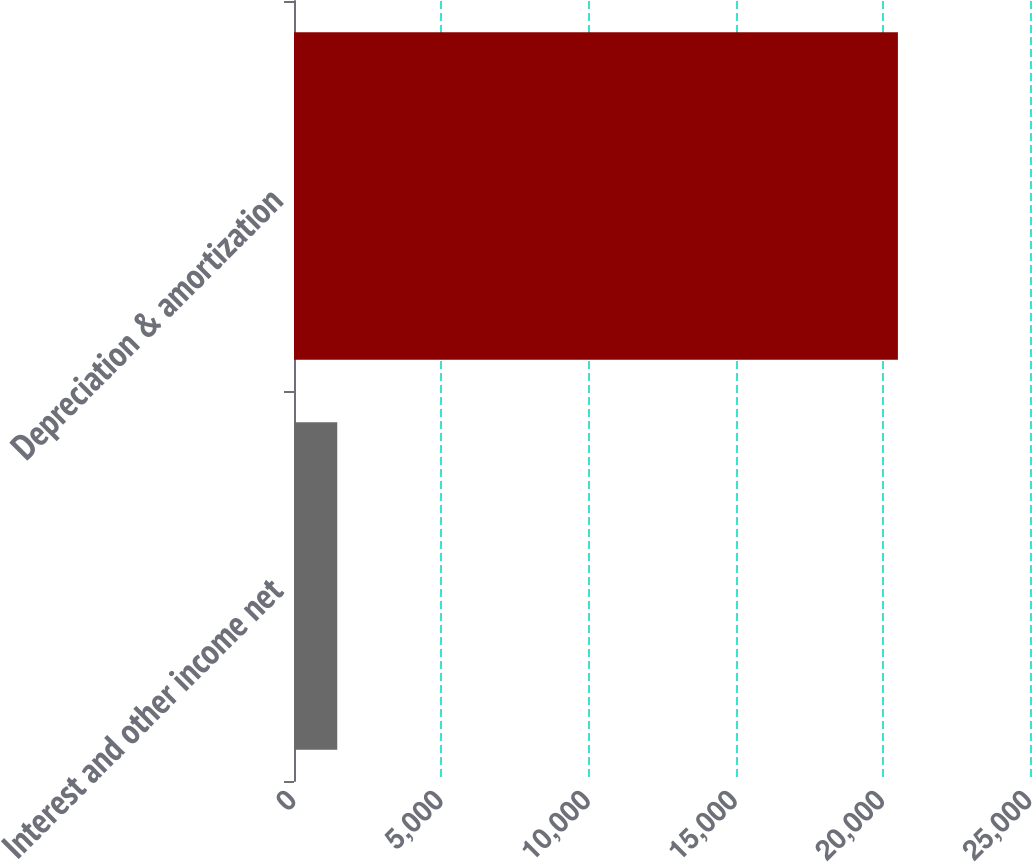Convert chart. <chart><loc_0><loc_0><loc_500><loc_500><bar_chart><fcel>Interest and other income net<fcel>Depreciation & amortization<nl><fcel>1469<fcel>20513<nl></chart> 